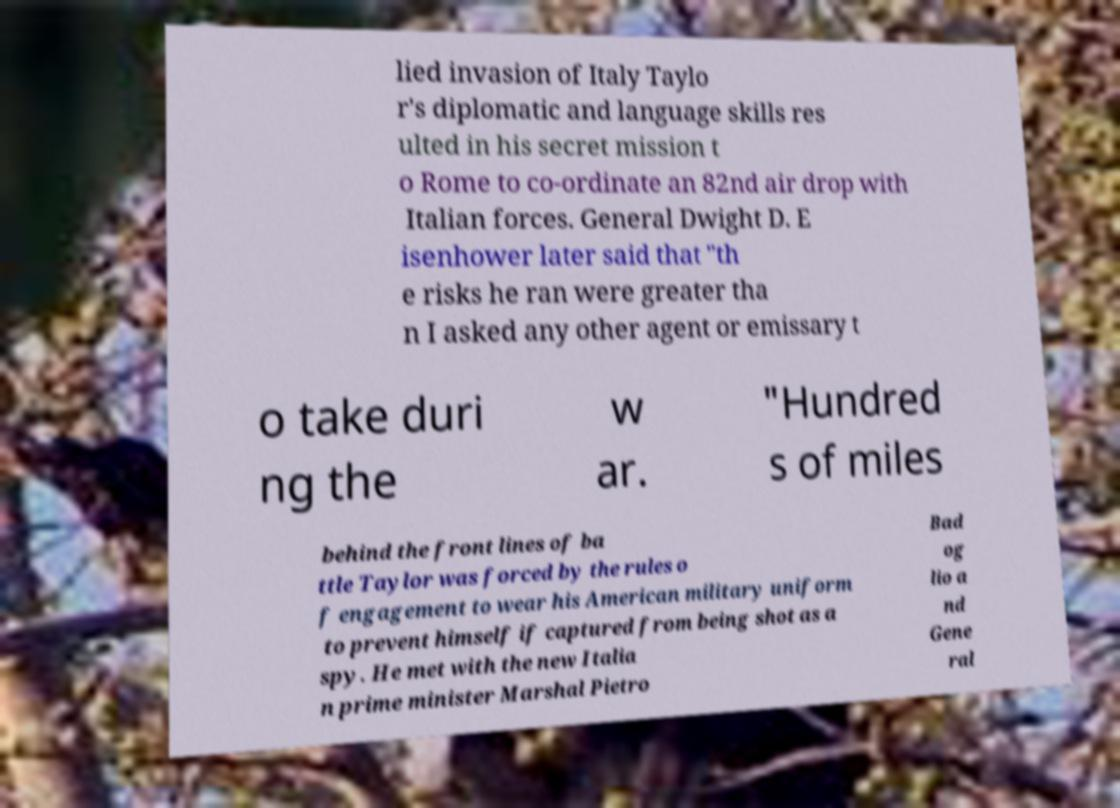There's text embedded in this image that I need extracted. Can you transcribe it verbatim? lied invasion of Italy Taylo r's diplomatic and language skills res ulted in his secret mission t o Rome to co-ordinate an 82nd air drop with Italian forces. General Dwight D. E isenhower later said that "th e risks he ran were greater tha n I asked any other agent or emissary t o take duri ng the w ar. "Hundred s of miles behind the front lines of ba ttle Taylor was forced by the rules o f engagement to wear his American military uniform to prevent himself if captured from being shot as a spy. He met with the new Italia n prime minister Marshal Pietro Bad og lio a nd Gene ral 